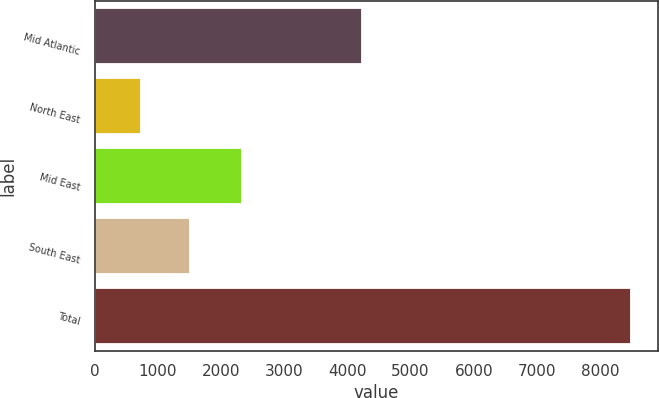<chart> <loc_0><loc_0><loc_500><loc_500><bar_chart><fcel>Mid Atlantic<fcel>North East<fcel>Mid East<fcel>South East<fcel>Total<nl><fcel>4238<fcel>728<fcel>2335<fcel>1503.9<fcel>8487<nl></chart> 